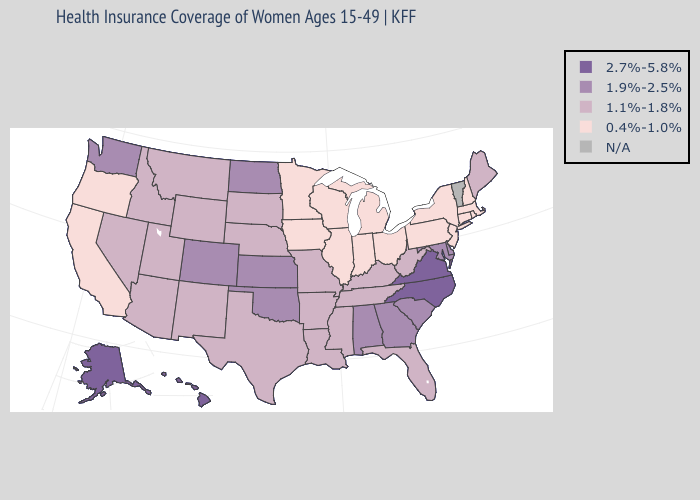What is the highest value in the West ?
Concise answer only. 2.7%-5.8%. Name the states that have a value in the range N/A?
Quick response, please. Vermont. Name the states that have a value in the range 1.1%-1.8%?
Answer briefly. Arizona, Arkansas, Florida, Idaho, Kentucky, Louisiana, Maine, Mississippi, Missouri, Montana, Nebraska, Nevada, New Mexico, South Dakota, Tennessee, Texas, Utah, West Virginia, Wyoming. What is the highest value in states that border Nebraska?
Be succinct. 1.9%-2.5%. Among the states that border North Carolina , does South Carolina have the highest value?
Give a very brief answer. No. Name the states that have a value in the range 1.1%-1.8%?
Answer briefly. Arizona, Arkansas, Florida, Idaho, Kentucky, Louisiana, Maine, Mississippi, Missouri, Montana, Nebraska, Nevada, New Mexico, South Dakota, Tennessee, Texas, Utah, West Virginia, Wyoming. Name the states that have a value in the range 2.7%-5.8%?
Keep it brief. Alaska, Hawaii, North Carolina, Virginia. What is the value of Hawaii?
Keep it brief. 2.7%-5.8%. Does Mississippi have the lowest value in the South?
Short answer required. Yes. What is the value of North Carolina?
Short answer required. 2.7%-5.8%. What is the value of Connecticut?
Short answer required. 0.4%-1.0%. Which states hav the highest value in the West?
Be succinct. Alaska, Hawaii. What is the lowest value in states that border Iowa?
Answer briefly. 0.4%-1.0%. 